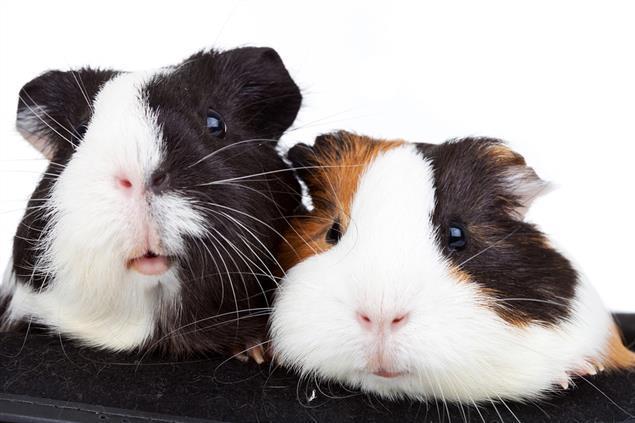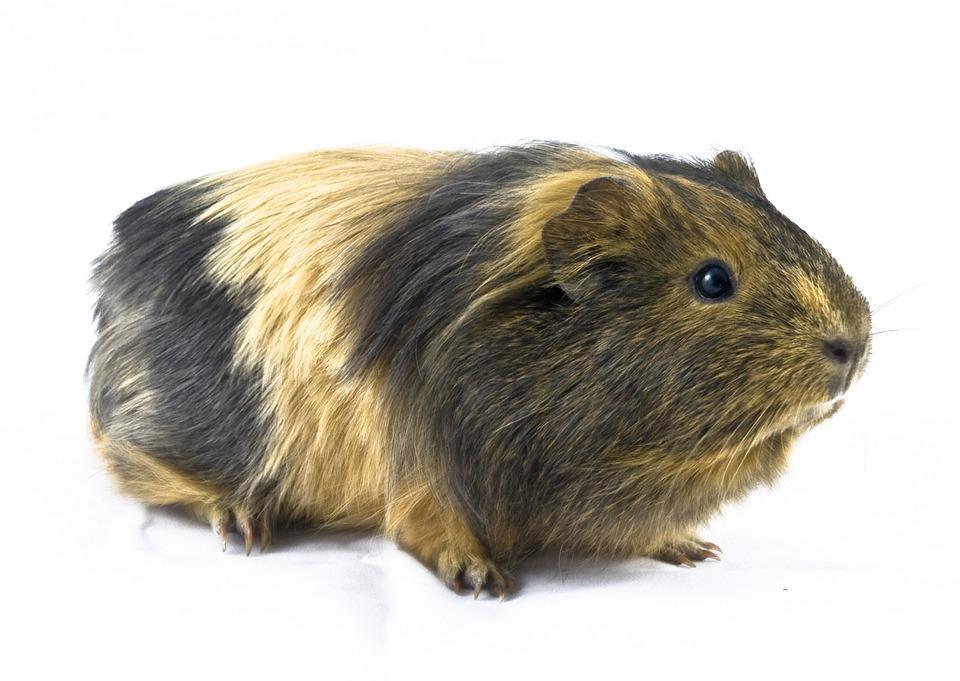The first image is the image on the left, the second image is the image on the right. For the images shown, is this caption "There are  4 guinea pigs in the pair" true? Answer yes or no. No. The first image is the image on the left, the second image is the image on the right. For the images displayed, is the sentence "One of the images shows exactly four furry animals." factually correct? Answer yes or no. No. 